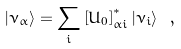<formula> <loc_0><loc_0><loc_500><loc_500>| \nu _ { \alpha } \rangle = \sum _ { i } \left [ U _ { 0 } \right ] _ { \alpha i } ^ { \ast } | \nu _ { i } \rangle \ ,</formula> 